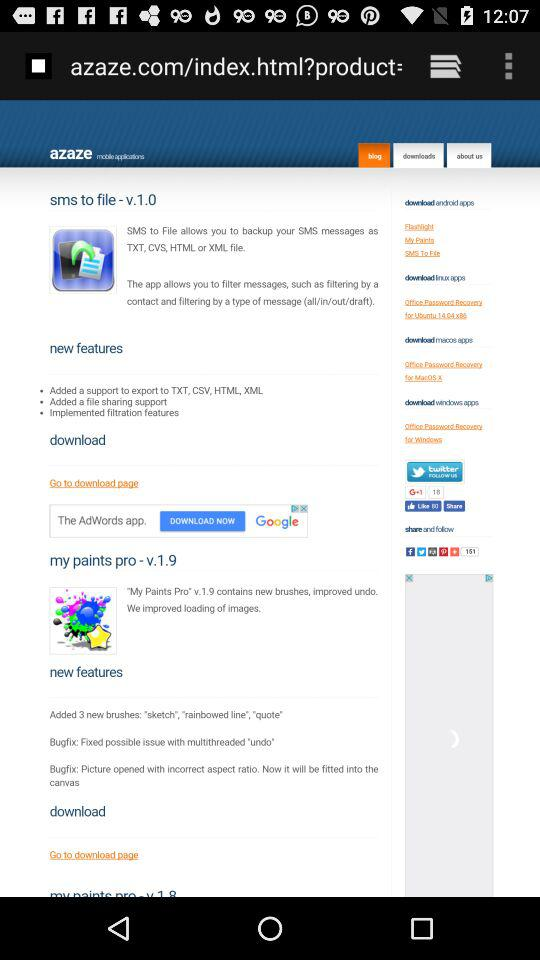What is the version of the application "my paints pro"? The version of the application is v.1.9. 